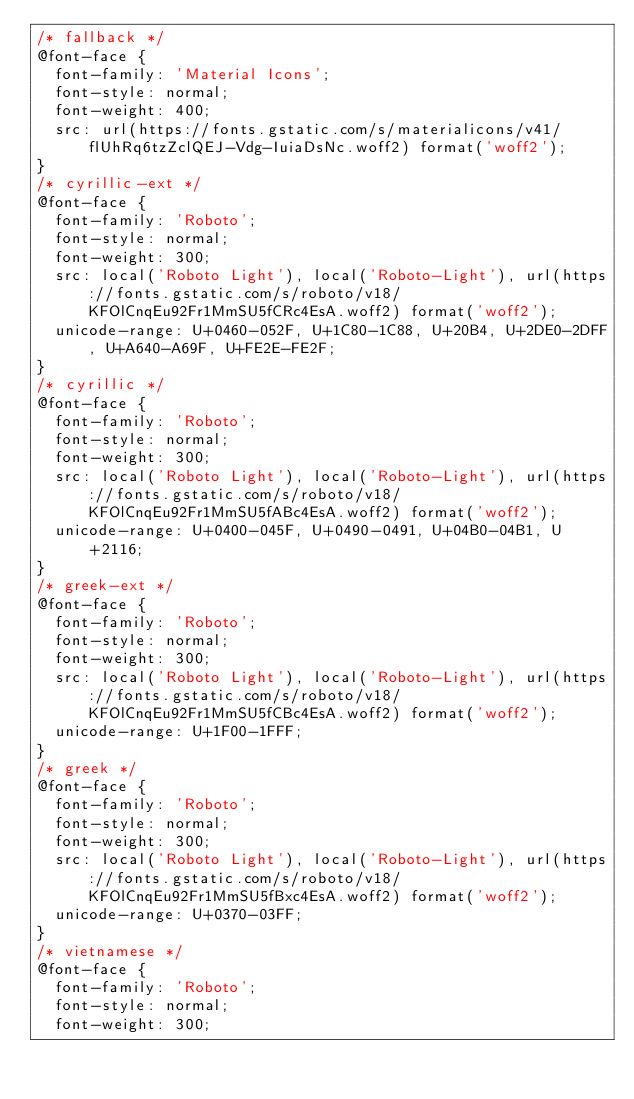<code> <loc_0><loc_0><loc_500><loc_500><_CSS_>/* fallback */
@font-face {
  font-family: 'Material Icons';
  font-style: normal;
  font-weight: 400;
  src: url(https://fonts.gstatic.com/s/materialicons/v41/flUhRq6tzZclQEJ-Vdg-IuiaDsNc.woff2) format('woff2');
}
/* cyrillic-ext */
@font-face {
  font-family: 'Roboto';
  font-style: normal;
  font-weight: 300;
  src: local('Roboto Light'), local('Roboto-Light'), url(https://fonts.gstatic.com/s/roboto/v18/KFOlCnqEu92Fr1MmSU5fCRc4EsA.woff2) format('woff2');
  unicode-range: U+0460-052F, U+1C80-1C88, U+20B4, U+2DE0-2DFF, U+A640-A69F, U+FE2E-FE2F;
}
/* cyrillic */
@font-face {
  font-family: 'Roboto';
  font-style: normal;
  font-weight: 300;
  src: local('Roboto Light'), local('Roboto-Light'), url(https://fonts.gstatic.com/s/roboto/v18/KFOlCnqEu92Fr1MmSU5fABc4EsA.woff2) format('woff2');
  unicode-range: U+0400-045F, U+0490-0491, U+04B0-04B1, U+2116;
}
/* greek-ext */
@font-face {
  font-family: 'Roboto';
  font-style: normal;
  font-weight: 300;
  src: local('Roboto Light'), local('Roboto-Light'), url(https://fonts.gstatic.com/s/roboto/v18/KFOlCnqEu92Fr1MmSU5fCBc4EsA.woff2) format('woff2');
  unicode-range: U+1F00-1FFF;
}
/* greek */
@font-face {
  font-family: 'Roboto';
  font-style: normal;
  font-weight: 300;
  src: local('Roboto Light'), local('Roboto-Light'), url(https://fonts.gstatic.com/s/roboto/v18/KFOlCnqEu92Fr1MmSU5fBxc4EsA.woff2) format('woff2');
  unicode-range: U+0370-03FF;
}
/* vietnamese */
@font-face {
  font-family: 'Roboto';
  font-style: normal;
  font-weight: 300;</code> 